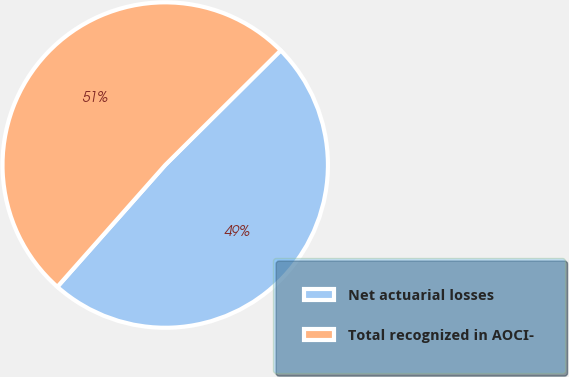Convert chart to OTSL. <chart><loc_0><loc_0><loc_500><loc_500><pie_chart><fcel>Net actuarial losses<fcel>Total recognized in AOCI-<nl><fcel>48.98%<fcel>51.02%<nl></chart> 